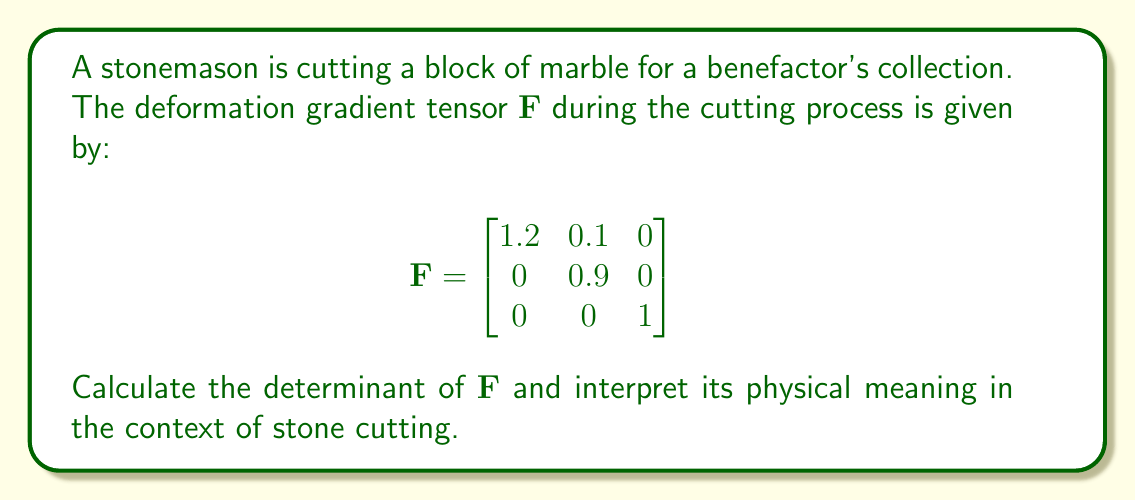Teach me how to tackle this problem. To solve this problem, we'll follow these steps:

1) Calculate the determinant of $\mathbf{F}$:
   The determinant of a 3x3 matrix is given by:
   $$\det(\mathbf{F}) = a_{11}(a_{22}a_{33} - a_{23}a_{32}) - a_{12}(a_{21}a_{33} - a_{23}a_{31}) + a_{13}(a_{21}a_{32} - a_{22}a_{31})$$

   Where $a_{ij}$ is the element in the i-th row and j-th column.

2) Substituting the values:
   $$\det(\mathbf{F}) = 1.2((0.9)(1) - (0)(0)) - 0.1((0)(1) - (0)(0)) + 0((0)(0) - (0.9)(0))$$

3) Simplifying:
   $$\det(\mathbf{F}) = 1.2(0.9) - 0 + 0 = 1.08$$

4) Interpretation:
   The determinant of the deformation gradient tensor represents the volume ratio between the deformed and undeformed configurations. In this case:

   - $\det(\mathbf{F}) > 1$ indicates a volume increase
   - $\det(\mathbf{F}) < 1$ indicates a volume decrease
   - $\det(\mathbf{F}) = 1$ indicates volume preservation

   Here, $\det(\mathbf{F}) = 1.08$, which is greater than 1.

5) In the context of stone cutting:
   This result suggests that the cutting process has caused a slight expansion of the stone, possibly due to stress relief or micro-fracturing. The volume has increased by 8% compared to the original block.
Answer: $\det(\mathbf{F}) = 1.08$, indicating an 8% volume increase during cutting. 